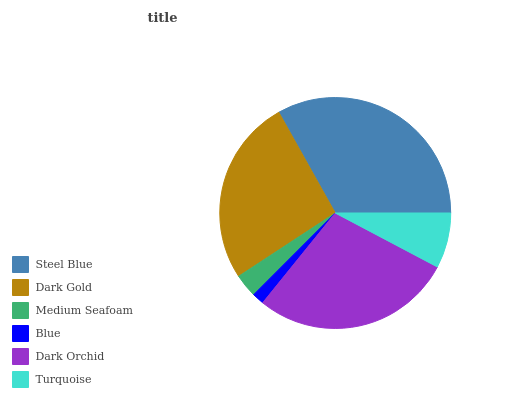Is Blue the minimum?
Answer yes or no. Yes. Is Steel Blue the maximum?
Answer yes or no. Yes. Is Dark Gold the minimum?
Answer yes or no. No. Is Dark Gold the maximum?
Answer yes or no. No. Is Steel Blue greater than Dark Gold?
Answer yes or no. Yes. Is Dark Gold less than Steel Blue?
Answer yes or no. Yes. Is Dark Gold greater than Steel Blue?
Answer yes or no. No. Is Steel Blue less than Dark Gold?
Answer yes or no. No. Is Dark Gold the high median?
Answer yes or no. Yes. Is Turquoise the low median?
Answer yes or no. Yes. Is Blue the high median?
Answer yes or no. No. Is Medium Seafoam the low median?
Answer yes or no. No. 